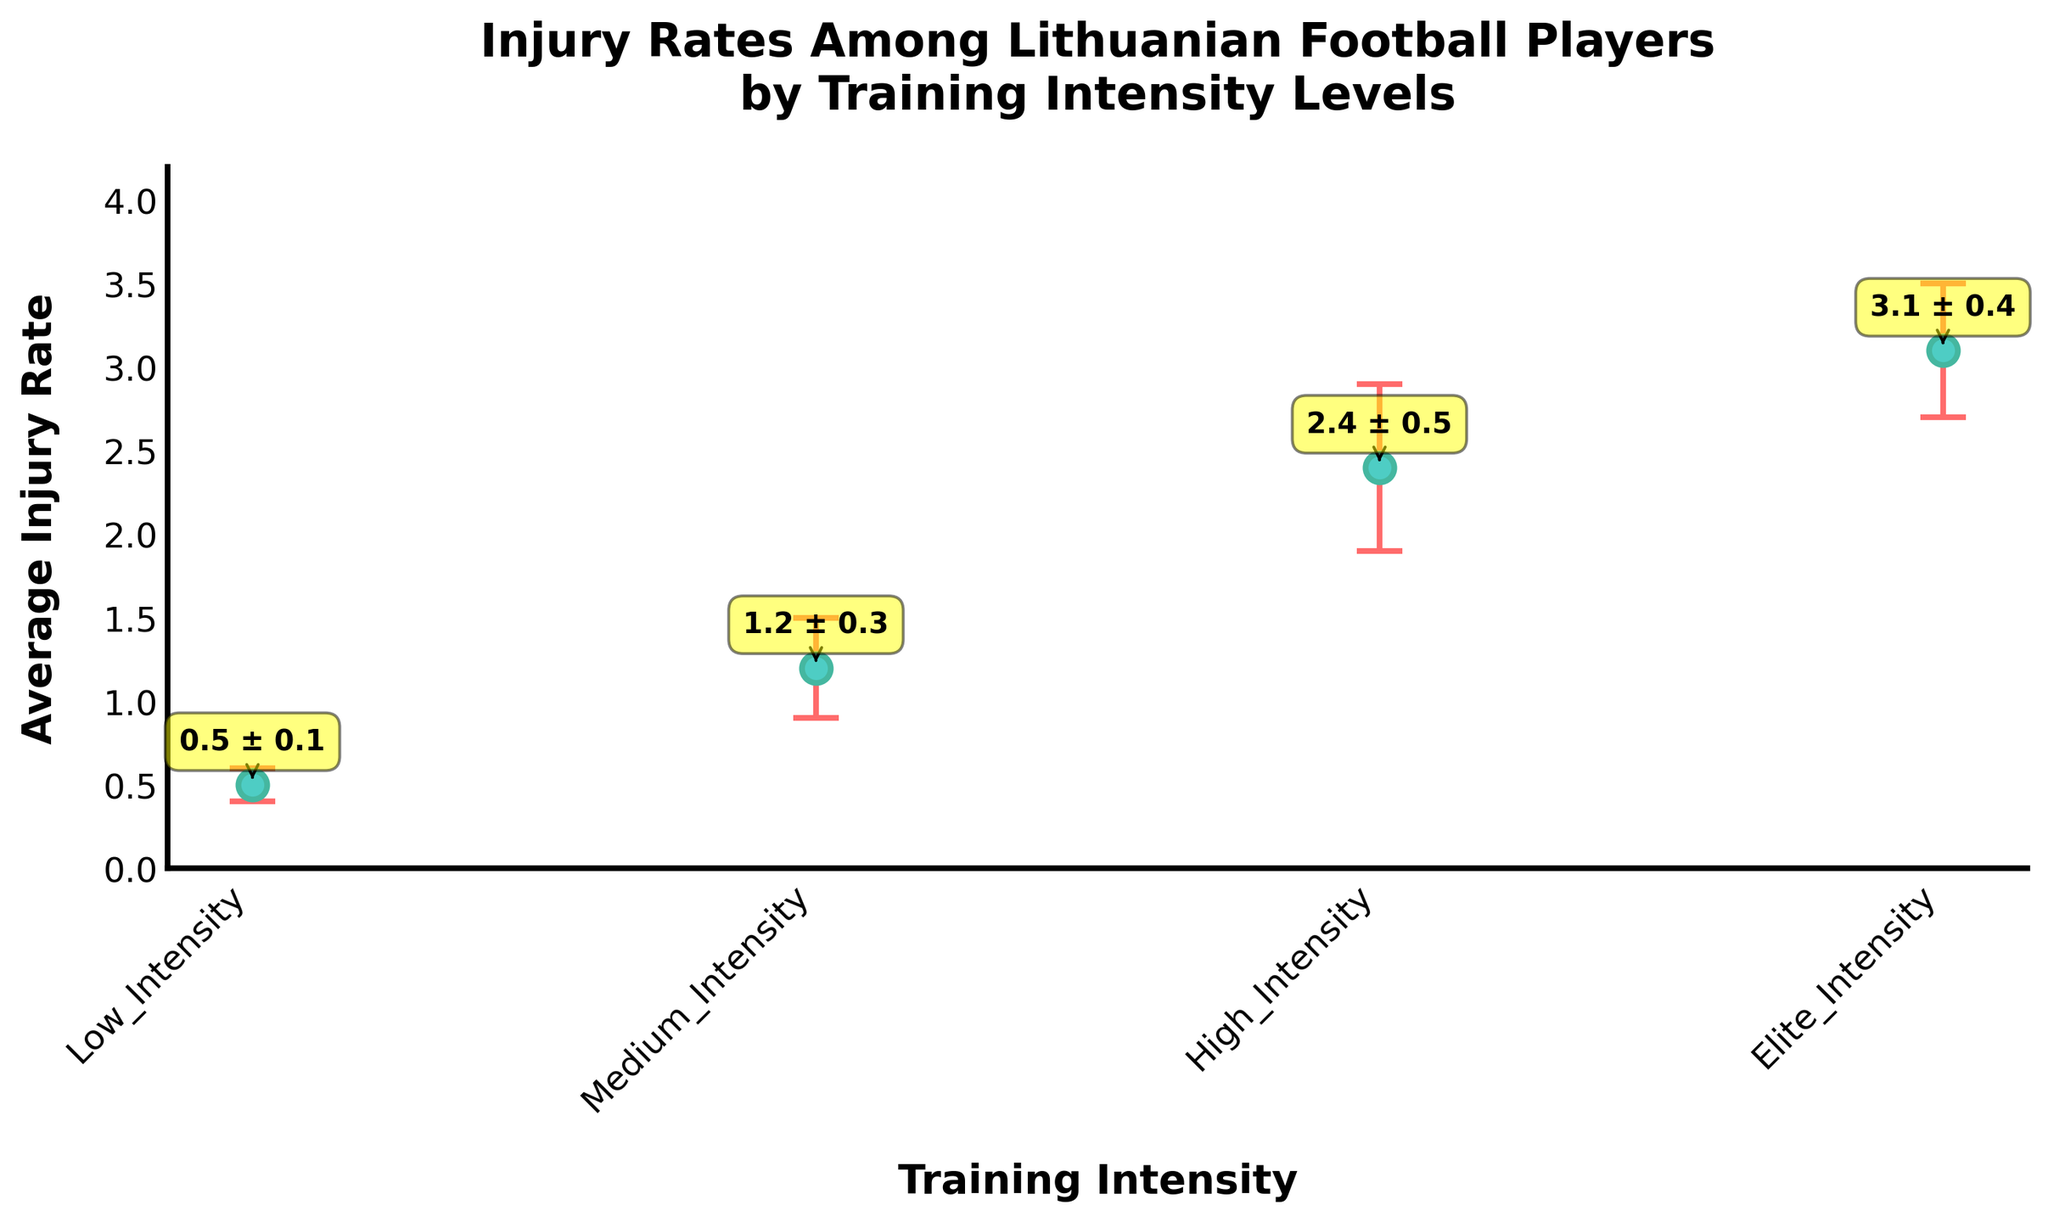What's the title of the figure? The title of the figure is displayed at the top of the plot. It reads "Injury Rates Among Lithuanian Football Players by Training Intensity Levels".
Answer: Injury Rates Among Lithuanian Football Players by Training Intensity Levels What is the average injury rate for players with Elite Intensity training? The data point for Elite Intensity shows an average injury rate, which is annotated directly on the figure next to the Elite Intensity data point.
Answer: 3.1 Which training intensity level has the highest average injury rate? By looking at the y-axis values and comparing the average injury rates for all levels, the highest value is under Elite Intensity with an average rate of 3.1.
Answer: Elite Intensity What is the difference in average injury rates between Medium Intensity and Low Intensity training levels? The average injury rates are 1.2 for Medium Intensity and 0.5 for Low Intensity. Subtracting 0.5 from 1.2 gives the difference.
Answer: 0.7 What is the range of the error bars for High Intensity training? The error bar value (standard deviation) for High Intensity is 0.5, so the range extends both above and below the average injury rate of 2.4 by 0.5.
Answer: 1.9 to 2.9 What training intensity level has the smallest standard deviation in injury rate? The smallest standard deviation is found by checking the y-error values for each training intensity. The Elite Intensity level has the smallest standard deviation of 0.4.
Answer: Elite Intensity Which two training intensity levels have the most similar average injury rates? By comparing the average injury rates, Medium Intensity (1.2) and High Intensity (2.4) are more distinct from each other compared to others. But Low Intensity (0.5) and Medium Intensity (1.2) are closer to each other.
Answer: Low Intensity and Medium Intensity What is the maximum value reached by the error bar for Medium Intensity? The average injury rate is 1.2, and the standard deviation is 0.3. Adding these together gives the maximum error bar value.
Answer: 1.5 How many training intensity levels are depicted in the figure? Count the distinct training intensity levels along the x-axis. There are Low, Medium, High, and Elite Intensity levels.
Answer: 4 